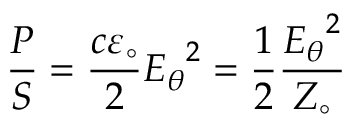<formula> <loc_0><loc_0><loc_500><loc_500>{ \frac { P } { S } } = { \frac { c \varepsilon _ { \circ } } { 2 } } { E _ { \theta } } ^ { 2 } = { \frac { 1 } { 2 } } { \frac { { E _ { \theta } } ^ { 2 } } { Z _ { \circ } } } \,</formula> 